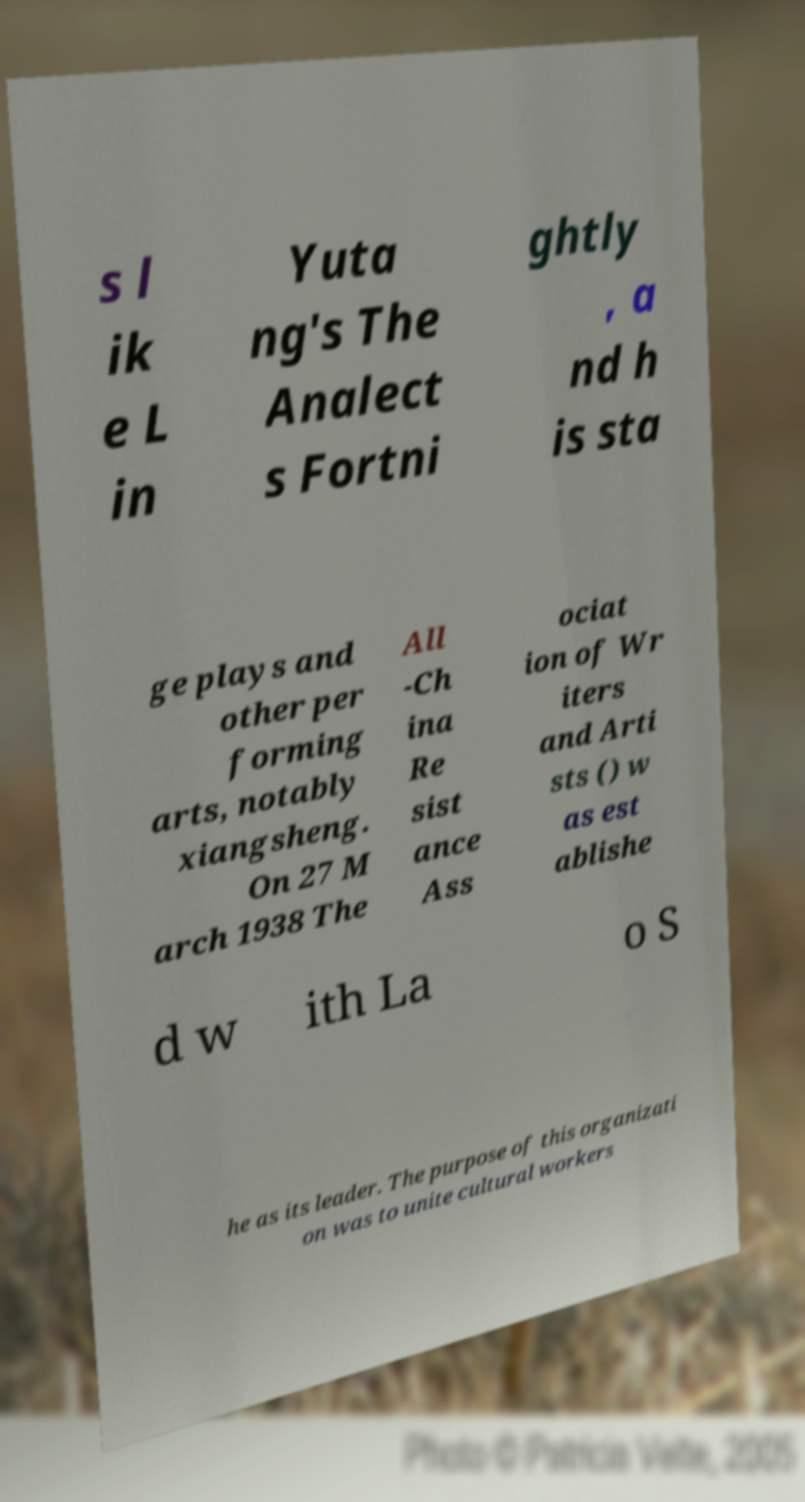What messages or text are displayed in this image? I need them in a readable, typed format. s l ik e L in Yuta ng's The Analect s Fortni ghtly , a nd h is sta ge plays and other per forming arts, notably xiangsheng. On 27 M arch 1938 The All -Ch ina Re sist ance Ass ociat ion of Wr iters and Arti sts () w as est ablishe d w ith La o S he as its leader. The purpose of this organizati on was to unite cultural workers 